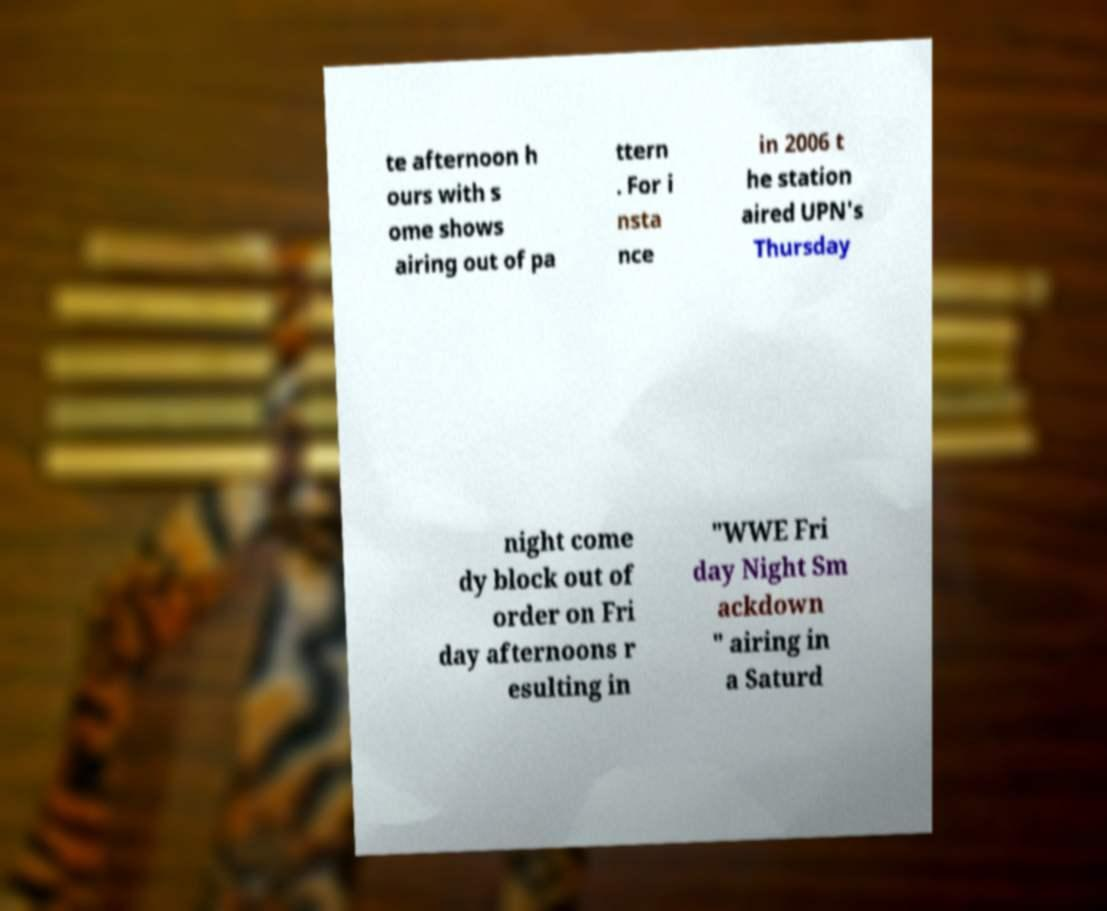I need the written content from this picture converted into text. Can you do that? te afternoon h ours with s ome shows airing out of pa ttern . For i nsta nce in 2006 t he station aired UPN's Thursday night come dy block out of order on Fri day afternoons r esulting in "WWE Fri day Night Sm ackdown " airing in a Saturd 